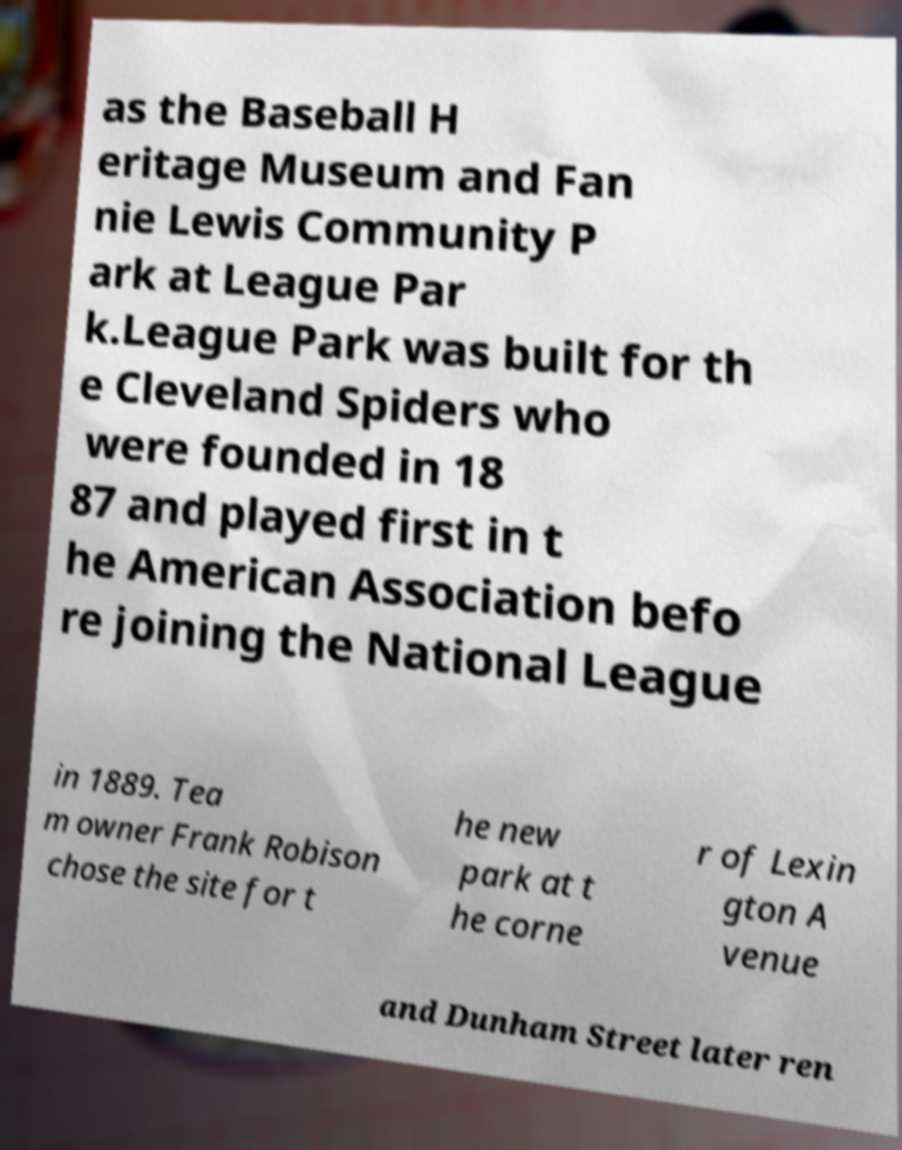There's text embedded in this image that I need extracted. Can you transcribe it verbatim? as the Baseball H eritage Museum and Fan nie Lewis Community P ark at League Par k.League Park was built for th e Cleveland Spiders who were founded in 18 87 and played first in t he American Association befo re joining the National League in 1889. Tea m owner Frank Robison chose the site for t he new park at t he corne r of Lexin gton A venue and Dunham Street later ren 